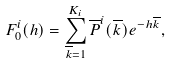Convert formula to latex. <formula><loc_0><loc_0><loc_500><loc_500>F _ { 0 } ^ { i } ( h ) = \sum _ { \overline { k } = 1 } ^ { K _ { i } } \overline { P } ^ { i } ( \overline { k } ) e ^ { - h \overline { k } } ,</formula> 